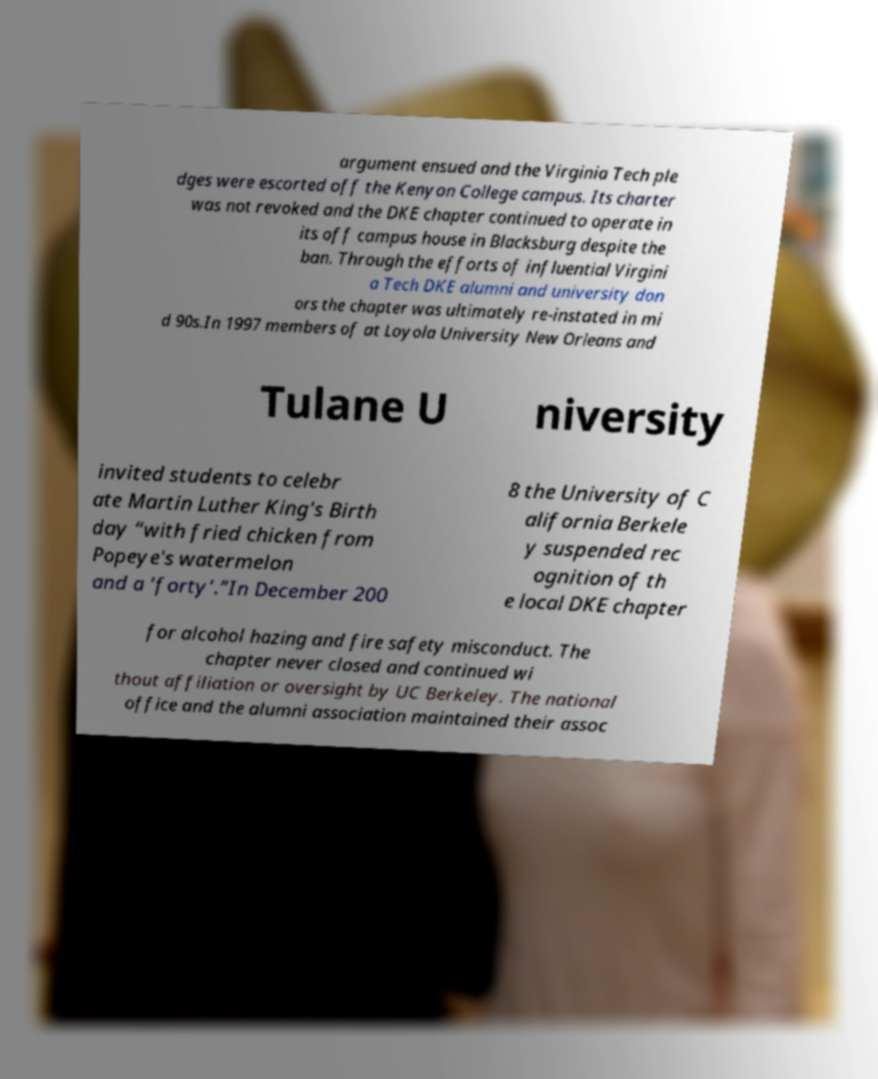For documentation purposes, I need the text within this image transcribed. Could you provide that? argument ensued and the Virginia Tech ple dges were escorted off the Kenyon College campus. Its charter was not revoked and the DKE chapter continued to operate in its off campus house in Blacksburg despite the ban. Through the efforts of influential Virgini a Tech DKE alumni and university don ors the chapter was ultimately re-instated in mi d 90s.In 1997 members of at Loyola University New Orleans and Tulane U niversity invited students to celebr ate Martin Luther King's Birth day “with fried chicken from Popeye's watermelon and a ‘forty’.”In December 200 8 the University of C alifornia Berkele y suspended rec ognition of th e local DKE chapter for alcohol hazing and fire safety misconduct. The chapter never closed and continued wi thout affiliation or oversight by UC Berkeley. The national office and the alumni association maintained their assoc 